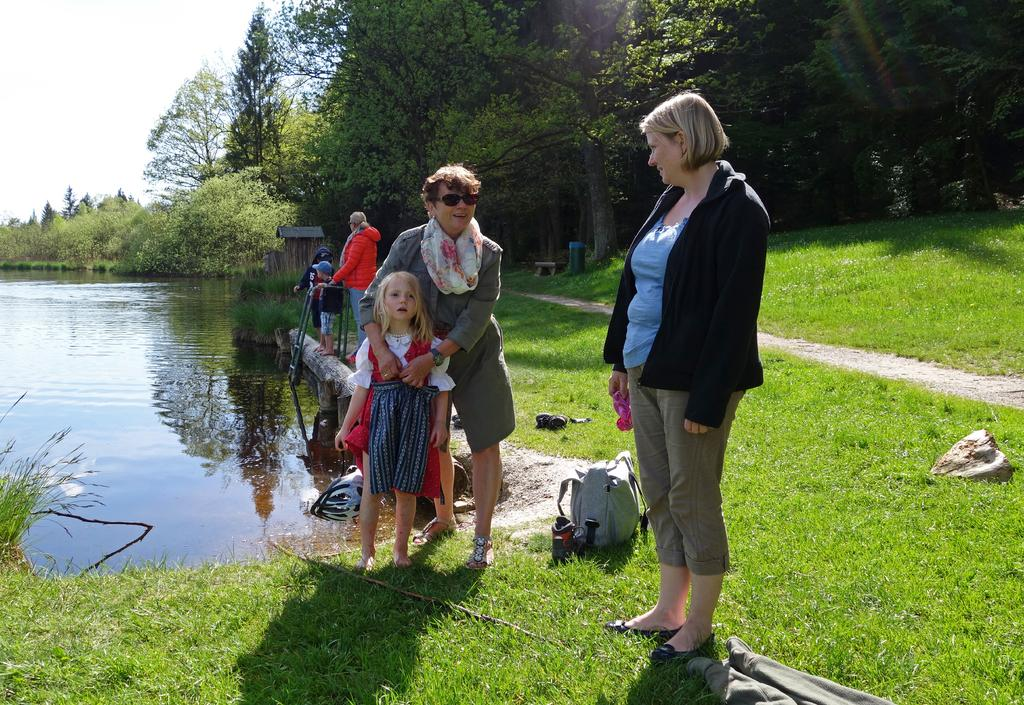What is happening in the image involving a group of people? There is a group of people standing in the image. What can be found on the grass in the image? There are items on the grass in the image. What natural element is visible in the image? There is water visible in the image. What type of vegetation is present in the image? There are trees in the image. What is visible in the background of the image? The sky is visible in the background of the image. What direction are the people in the image facing? The provided facts do not indicate the direction the people are facing, so it cannot be determined from the image. What attraction can be seen in the image? There is no specific attraction mentioned or visible in the image; it simply shows a group of people standing near items on the grass, with water, trees, and the sky in the background. 